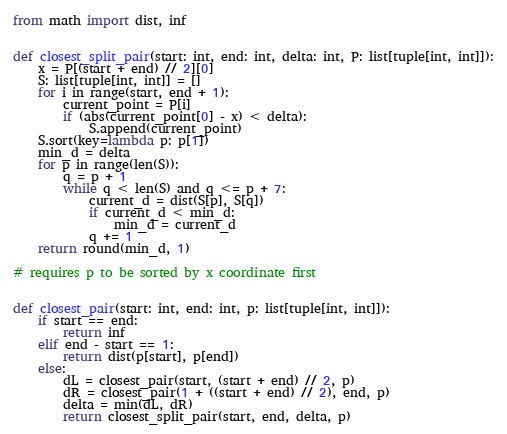Convert code to text. <code><loc_0><loc_0><loc_500><loc_500><_Python_>from math import dist, inf


def closest_split_pair(start: int, end: int, delta: int, P: list[tuple[int, int]]):
    x = P[(start + end) // 2][0]
    S: list[tuple[int, int]] = []
    for i in range(start, end + 1):
        current_point = P[i]
        if (abs(current_point[0] - x) < delta):
            S.append(current_point)
    S.sort(key=lambda p: p[1])
    min_d = delta
    for p in range(len(S)):
        q = p + 1
        while q < len(S) and q <= p + 7:
            current_d = dist(S[p], S[q])
            if current_d < min_d:
                min_d = current_d
            q += 1
    return round(min_d, 1)

# requires p to be sorted by x coordinate first


def closest_pair(start: int, end: int, p: list[tuple[int, int]]):
    if start == end:
        return inf
    elif end - start == 1:
        return dist(p[start], p[end])
    else:
        dL = closest_pair(start, (start + end) // 2, p)
        dR = closest_pair(1 + ((start + end) // 2), end, p)
        delta = min(dL, dR)
        return closest_split_pair(start, end, delta, p)
</code> 